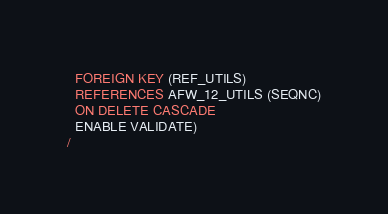<code> <loc_0><loc_0><loc_500><loc_500><_SQL_>  FOREIGN KEY (REF_UTILS) 
  REFERENCES AFW_12_UTILS (SEQNC)
  ON DELETE CASCADE
  ENABLE VALIDATE)
/
</code> 